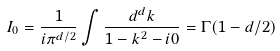Convert formula to latex. <formula><loc_0><loc_0><loc_500><loc_500>I _ { 0 } = \frac { 1 } { i \pi ^ { d / 2 } } \int \frac { d ^ { d } k } { 1 - k ^ { 2 } - i 0 } = \Gamma ( 1 - d / 2 )</formula> 